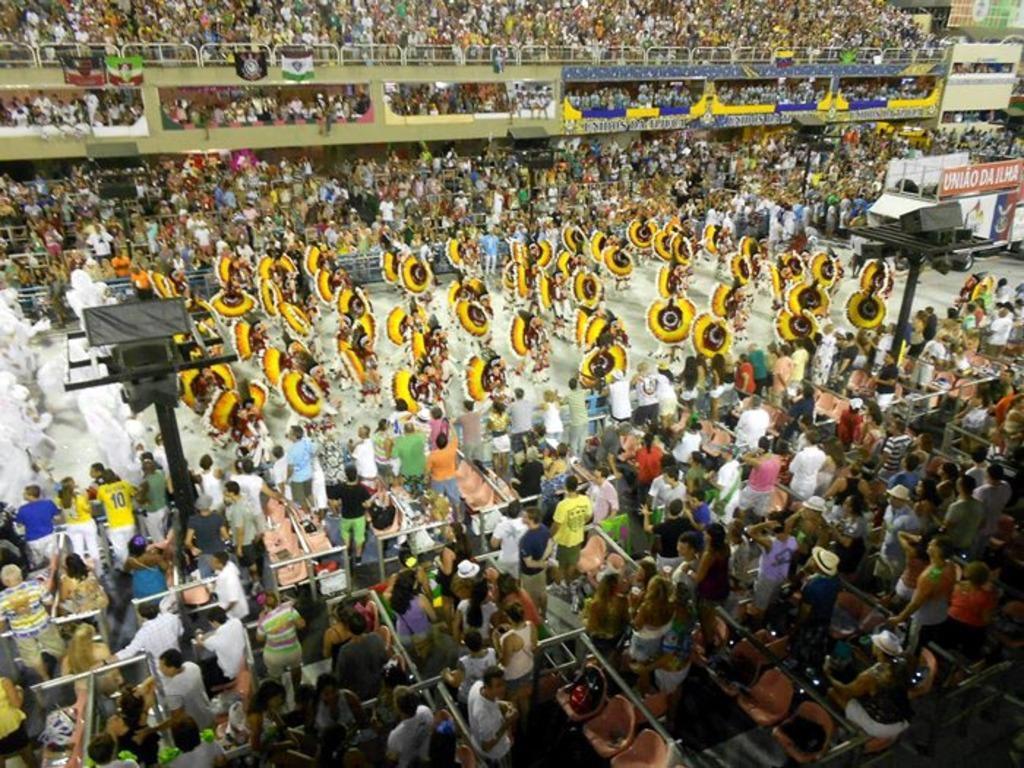Please provide a concise description of this image. In this picture I can observe some people dancing in the middle of the picture. I can observe chairs in the bottom of the picture. In the background there are some people. There are men and women in this picture. 